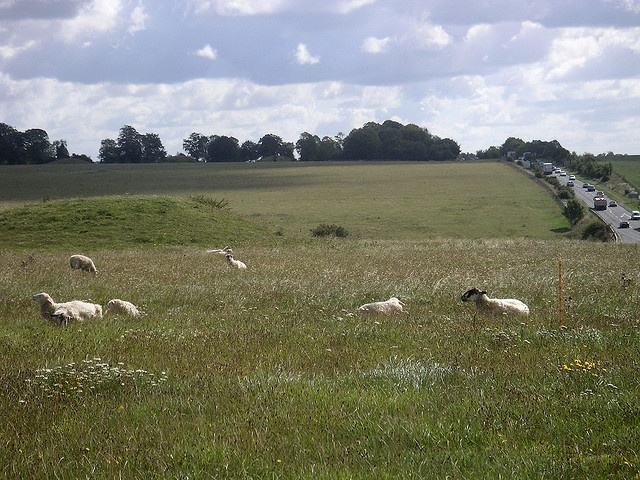Describe the objects in this image and their specific colors. I can see sheep in darkgray, ivory, black, and gray tones, sheep in darkgray, ivory, lightgray, and gray tones, sheep in darkgray, gray, ivory, and olive tones, sheep in darkgray, darkgreen, gray, and beige tones, and sheep in darkgray, black, and gray tones in this image. 